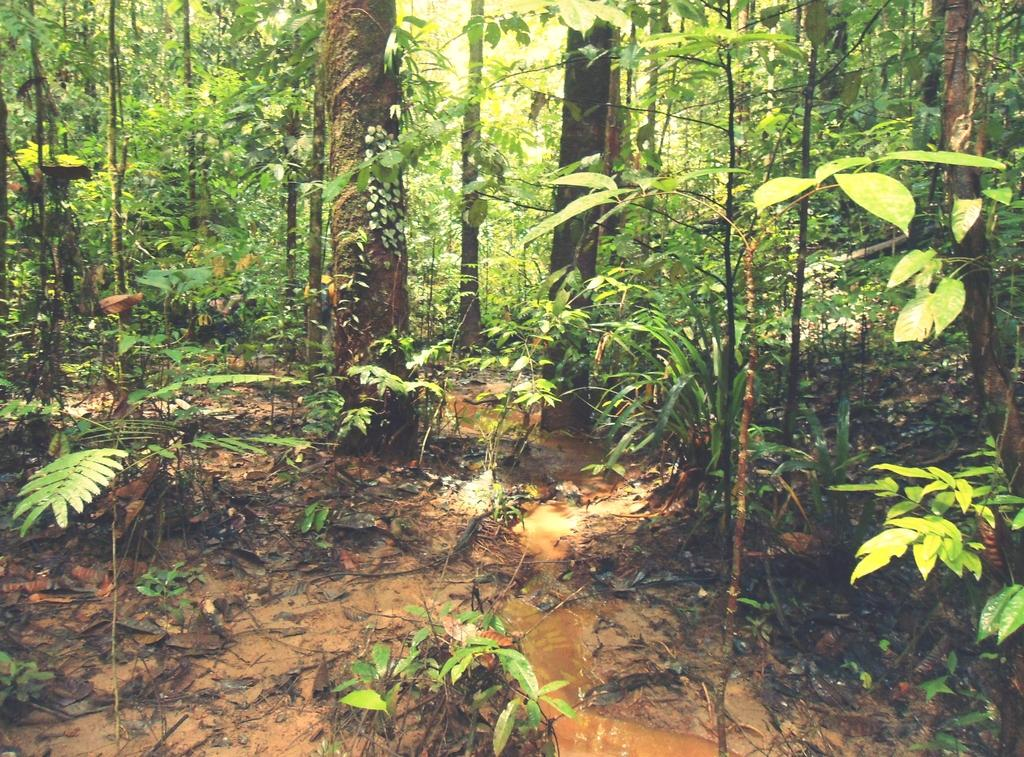What type of vegetation can be seen in the image? There are trees in the image. What is happening with the water in the image? Water is flowing in the image. What else can be found on the ground in the image? There are plants on the ground in the image. Are there any pigs visible in the image? No, there are no pigs present in the image. What type of coast can be seen in the image? There is no coast visible in the image; it features trees, water, and plants. 